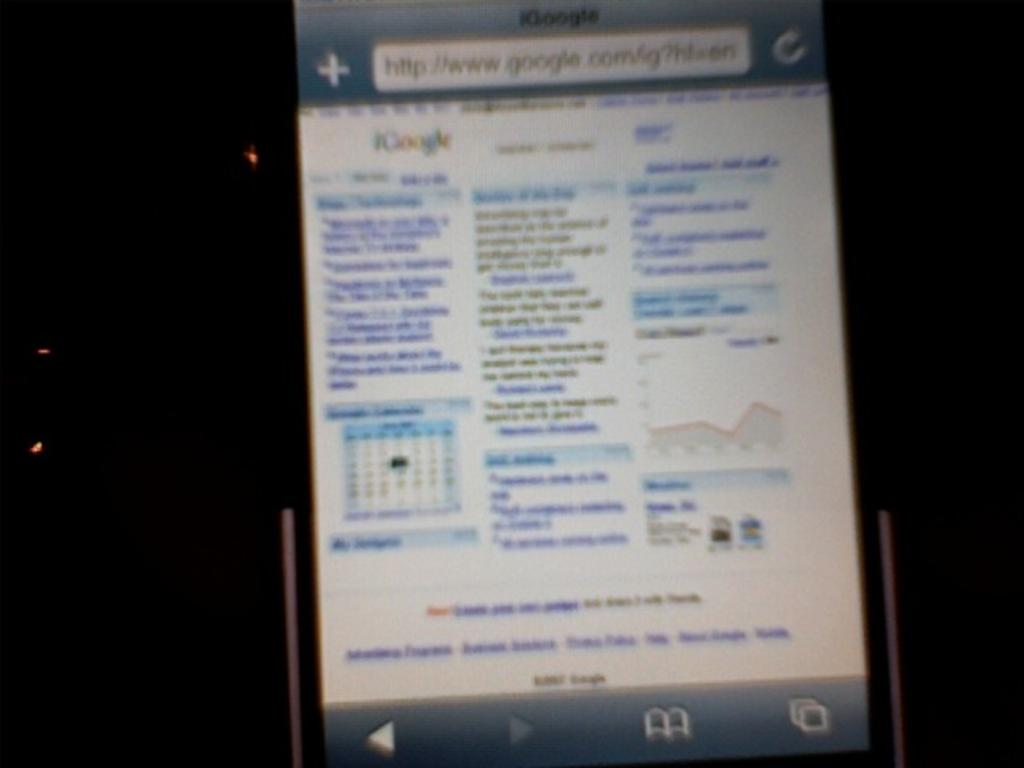<image>
Present a compact description of the photo's key features. A smartphone with a display screen of www.google.com 